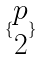Convert formula to latex. <formula><loc_0><loc_0><loc_500><loc_500>\{ \begin{matrix} p \\ 2 \end{matrix} \}</formula> 